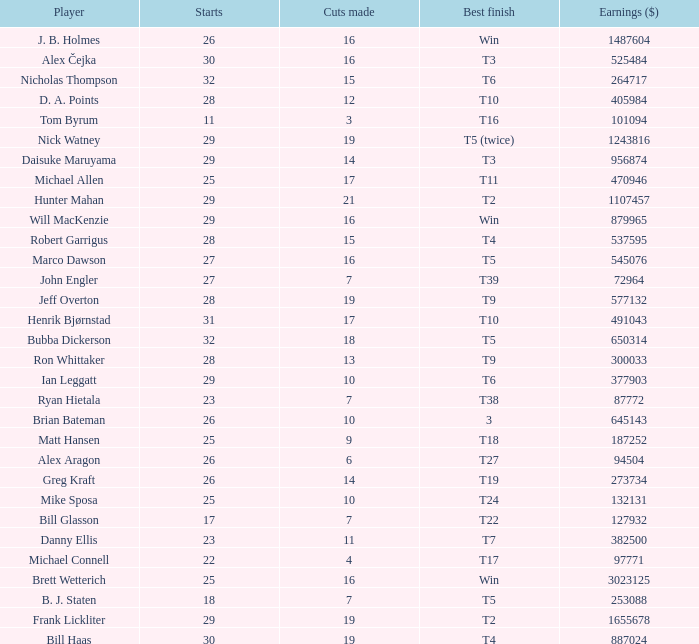What is the maximum money list rank for Matt Hansen? 194.0. 